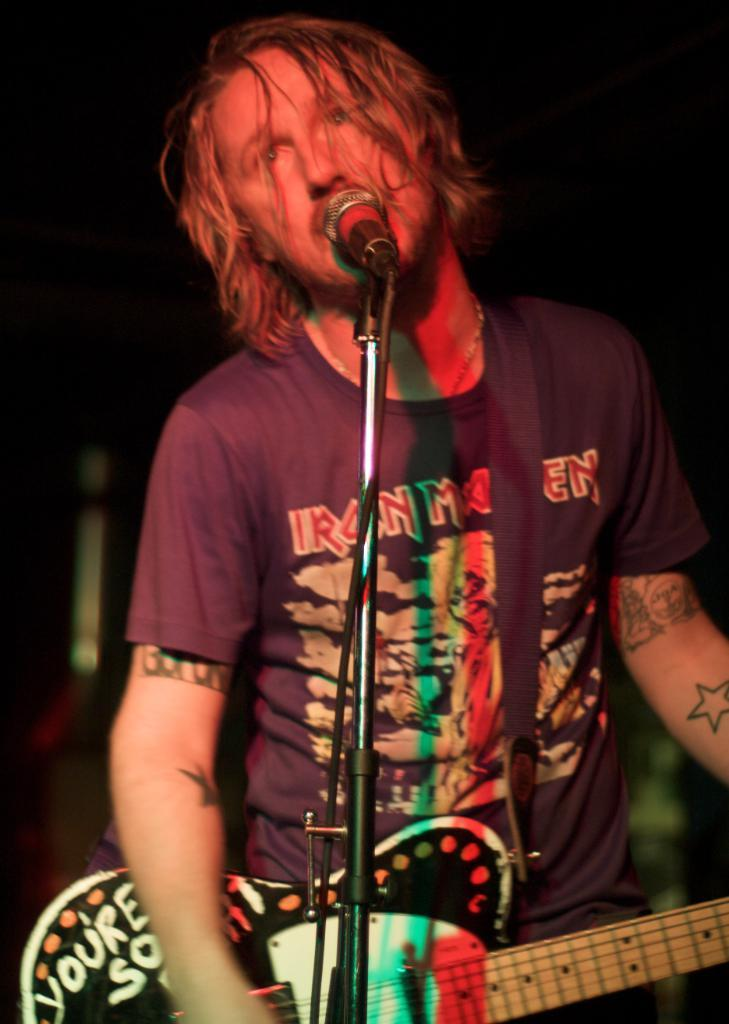What is the main subject of the image? There is a person in the image. What is the person doing in the image? The person is standing in front of a microphone and playing a guitar. What type of bear can be seen playing the guitar in the image? There is no bear present in the image, and therefore no such activity can be observed. Can you tell me how many bottles are visible in the image? There is no mention of bottles in the provided facts, so it cannot be determined from the image. 